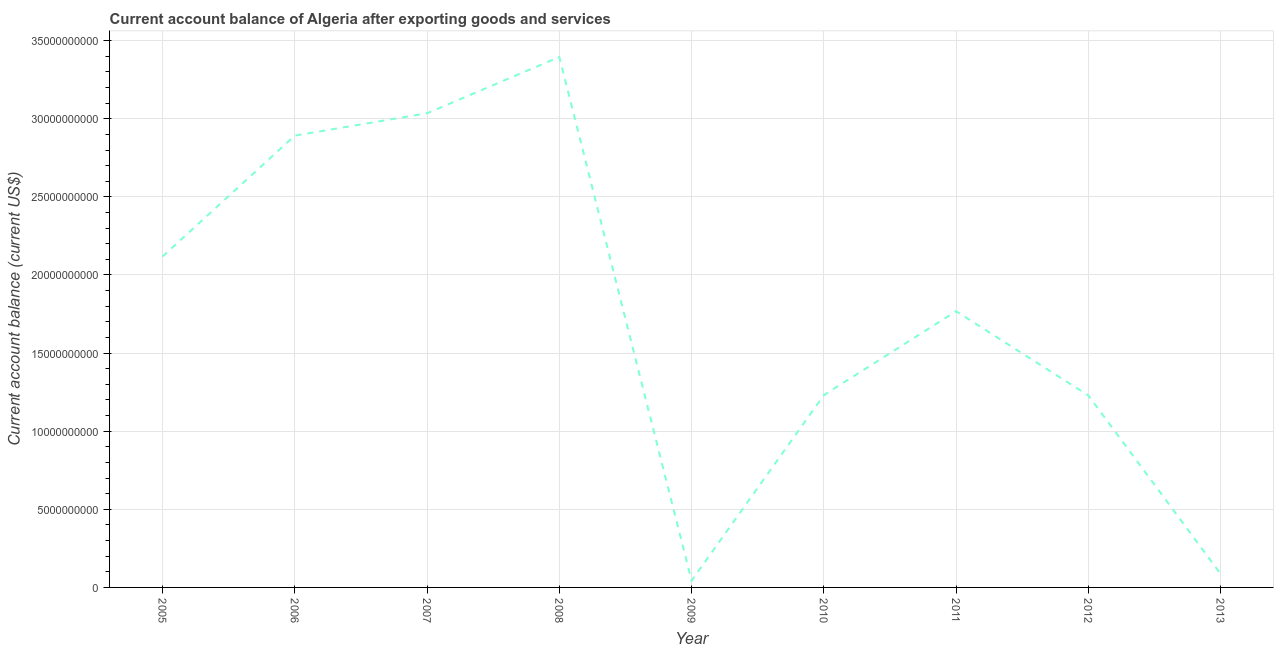What is the current account balance in 2006?
Your response must be concise. 2.89e+1. Across all years, what is the maximum current account balance?
Give a very brief answer. 3.40e+1. Across all years, what is the minimum current account balance?
Give a very brief answer. 4.34e+08. In which year was the current account balance minimum?
Offer a very short reply. 2009. What is the sum of the current account balance?
Your answer should be very brief. 1.58e+11. What is the difference between the current account balance in 2007 and 2009?
Offer a very short reply. 2.99e+1. What is the average current account balance per year?
Give a very brief answer. 1.76e+1. What is the median current account balance?
Provide a succinct answer. 1.77e+1. In how many years, is the current account balance greater than 7000000000 US$?
Provide a short and direct response. 7. What is the ratio of the current account balance in 2005 to that in 2006?
Provide a succinct answer. 0.73. Is the current account balance in 2008 less than that in 2013?
Offer a very short reply. No. Is the difference between the current account balance in 2007 and 2011 greater than the difference between any two years?
Your response must be concise. No. What is the difference between the highest and the second highest current account balance?
Offer a very short reply. 3.60e+09. What is the difference between the highest and the lowest current account balance?
Provide a short and direct response. 3.35e+1. How many lines are there?
Your answer should be very brief. 1. How many years are there in the graph?
Your answer should be compact. 9. Does the graph contain grids?
Offer a very short reply. Yes. What is the title of the graph?
Provide a succinct answer. Current account balance of Algeria after exporting goods and services. What is the label or title of the X-axis?
Provide a succinct answer. Year. What is the label or title of the Y-axis?
Make the answer very short. Current account balance (current US$). What is the Current account balance (current US$) in 2005?
Provide a succinct answer. 2.12e+1. What is the Current account balance (current US$) of 2006?
Ensure brevity in your answer.  2.89e+1. What is the Current account balance (current US$) in 2007?
Keep it short and to the point. 3.04e+1. What is the Current account balance (current US$) in 2008?
Your answer should be very brief. 3.40e+1. What is the Current account balance (current US$) of 2009?
Provide a short and direct response. 4.34e+08. What is the Current account balance (current US$) of 2010?
Make the answer very short. 1.23e+1. What is the Current account balance (current US$) of 2011?
Your answer should be very brief. 1.77e+1. What is the Current account balance (current US$) of 2012?
Make the answer very short. 1.23e+1. What is the Current account balance (current US$) in 2013?
Your answer should be very brief. 8.69e+08. What is the difference between the Current account balance (current US$) in 2005 and 2006?
Your answer should be very brief. -7.74e+09. What is the difference between the Current account balance (current US$) in 2005 and 2007?
Give a very brief answer. -9.17e+09. What is the difference between the Current account balance (current US$) in 2005 and 2008?
Provide a short and direct response. -1.28e+1. What is the difference between the Current account balance (current US$) in 2005 and 2009?
Ensure brevity in your answer.  2.07e+1. What is the difference between the Current account balance (current US$) in 2005 and 2010?
Your response must be concise. 8.87e+09. What is the difference between the Current account balance (current US$) in 2005 and 2011?
Your answer should be compact. 3.50e+09. What is the difference between the Current account balance (current US$) in 2005 and 2012?
Your response must be concise. 8.89e+09. What is the difference between the Current account balance (current US$) in 2005 and 2013?
Provide a short and direct response. 2.03e+1. What is the difference between the Current account balance (current US$) in 2006 and 2007?
Your answer should be very brief. -1.43e+09. What is the difference between the Current account balance (current US$) in 2006 and 2008?
Provide a succinct answer. -5.03e+09. What is the difference between the Current account balance (current US$) in 2006 and 2009?
Ensure brevity in your answer.  2.85e+1. What is the difference between the Current account balance (current US$) in 2006 and 2010?
Offer a very short reply. 1.66e+1. What is the difference between the Current account balance (current US$) in 2006 and 2011?
Offer a terse response. 1.12e+1. What is the difference between the Current account balance (current US$) in 2006 and 2012?
Give a very brief answer. 1.66e+1. What is the difference between the Current account balance (current US$) in 2006 and 2013?
Provide a short and direct response. 2.81e+1. What is the difference between the Current account balance (current US$) in 2007 and 2008?
Keep it short and to the point. -3.60e+09. What is the difference between the Current account balance (current US$) in 2007 and 2009?
Give a very brief answer. 2.99e+1. What is the difference between the Current account balance (current US$) in 2007 and 2010?
Your answer should be compact. 1.80e+1. What is the difference between the Current account balance (current US$) in 2007 and 2011?
Your response must be concise. 1.27e+1. What is the difference between the Current account balance (current US$) in 2007 and 2012?
Provide a succinct answer. 1.81e+1. What is the difference between the Current account balance (current US$) in 2007 and 2013?
Your response must be concise. 2.95e+1. What is the difference between the Current account balance (current US$) in 2008 and 2009?
Give a very brief answer. 3.35e+1. What is the difference between the Current account balance (current US$) in 2008 and 2010?
Your response must be concise. 2.16e+1. What is the difference between the Current account balance (current US$) in 2008 and 2011?
Your answer should be very brief. 1.63e+1. What is the difference between the Current account balance (current US$) in 2008 and 2012?
Your answer should be compact. 2.17e+1. What is the difference between the Current account balance (current US$) in 2008 and 2013?
Provide a succinct answer. 3.31e+1. What is the difference between the Current account balance (current US$) in 2009 and 2010?
Ensure brevity in your answer.  -1.19e+1. What is the difference between the Current account balance (current US$) in 2009 and 2011?
Your answer should be very brief. -1.72e+1. What is the difference between the Current account balance (current US$) in 2009 and 2012?
Give a very brief answer. -1.19e+1. What is the difference between the Current account balance (current US$) in 2009 and 2013?
Your answer should be very brief. -4.35e+08. What is the difference between the Current account balance (current US$) in 2010 and 2011?
Your response must be concise. -5.37e+09. What is the difference between the Current account balance (current US$) in 2010 and 2012?
Your answer should be very brief. 1.95e+07. What is the difference between the Current account balance (current US$) in 2010 and 2013?
Keep it short and to the point. 1.14e+1. What is the difference between the Current account balance (current US$) in 2011 and 2012?
Keep it short and to the point. 5.39e+09. What is the difference between the Current account balance (current US$) in 2011 and 2013?
Offer a very short reply. 1.68e+1. What is the difference between the Current account balance (current US$) in 2012 and 2013?
Offer a very short reply. 1.14e+1. What is the ratio of the Current account balance (current US$) in 2005 to that in 2006?
Your response must be concise. 0.73. What is the ratio of the Current account balance (current US$) in 2005 to that in 2007?
Your answer should be very brief. 0.7. What is the ratio of the Current account balance (current US$) in 2005 to that in 2008?
Provide a succinct answer. 0.62. What is the ratio of the Current account balance (current US$) in 2005 to that in 2009?
Your answer should be very brief. 48.8. What is the ratio of the Current account balance (current US$) in 2005 to that in 2010?
Provide a succinct answer. 1.72. What is the ratio of the Current account balance (current US$) in 2005 to that in 2011?
Keep it short and to the point. 1.2. What is the ratio of the Current account balance (current US$) in 2005 to that in 2012?
Give a very brief answer. 1.72. What is the ratio of the Current account balance (current US$) in 2005 to that in 2013?
Your answer should be very brief. 24.37. What is the ratio of the Current account balance (current US$) in 2006 to that in 2007?
Keep it short and to the point. 0.95. What is the ratio of the Current account balance (current US$) in 2006 to that in 2008?
Provide a succinct answer. 0.85. What is the ratio of the Current account balance (current US$) in 2006 to that in 2009?
Ensure brevity in your answer.  66.64. What is the ratio of the Current account balance (current US$) in 2006 to that in 2010?
Ensure brevity in your answer.  2.35. What is the ratio of the Current account balance (current US$) in 2006 to that in 2011?
Make the answer very short. 1.64. What is the ratio of the Current account balance (current US$) in 2006 to that in 2012?
Provide a short and direct response. 2.35. What is the ratio of the Current account balance (current US$) in 2006 to that in 2013?
Ensure brevity in your answer.  33.27. What is the ratio of the Current account balance (current US$) in 2007 to that in 2008?
Your answer should be very brief. 0.89. What is the ratio of the Current account balance (current US$) in 2007 to that in 2009?
Your answer should be very brief. 69.94. What is the ratio of the Current account balance (current US$) in 2007 to that in 2010?
Offer a terse response. 2.47. What is the ratio of the Current account balance (current US$) in 2007 to that in 2011?
Your response must be concise. 1.72. What is the ratio of the Current account balance (current US$) in 2007 to that in 2012?
Keep it short and to the point. 2.47. What is the ratio of the Current account balance (current US$) in 2007 to that in 2013?
Keep it short and to the point. 34.92. What is the ratio of the Current account balance (current US$) in 2008 to that in 2009?
Offer a very short reply. 78.24. What is the ratio of the Current account balance (current US$) in 2008 to that in 2010?
Provide a succinct answer. 2.76. What is the ratio of the Current account balance (current US$) in 2008 to that in 2011?
Offer a terse response. 1.92. What is the ratio of the Current account balance (current US$) in 2008 to that in 2012?
Your answer should be very brief. 2.76. What is the ratio of the Current account balance (current US$) in 2008 to that in 2013?
Provide a succinct answer. 39.06. What is the ratio of the Current account balance (current US$) in 2009 to that in 2010?
Keep it short and to the point. 0.04. What is the ratio of the Current account balance (current US$) in 2009 to that in 2011?
Provide a short and direct response. 0.03. What is the ratio of the Current account balance (current US$) in 2009 to that in 2012?
Offer a terse response. 0.04. What is the ratio of the Current account balance (current US$) in 2009 to that in 2013?
Offer a terse response. 0.5. What is the ratio of the Current account balance (current US$) in 2010 to that in 2011?
Provide a succinct answer. 0.7. What is the ratio of the Current account balance (current US$) in 2010 to that in 2012?
Your answer should be compact. 1. What is the ratio of the Current account balance (current US$) in 2010 to that in 2013?
Your answer should be compact. 14.16. What is the ratio of the Current account balance (current US$) in 2011 to that in 2012?
Your answer should be compact. 1.44. What is the ratio of the Current account balance (current US$) in 2011 to that in 2013?
Provide a short and direct response. 20.34. What is the ratio of the Current account balance (current US$) in 2012 to that in 2013?
Provide a short and direct response. 14.14. 